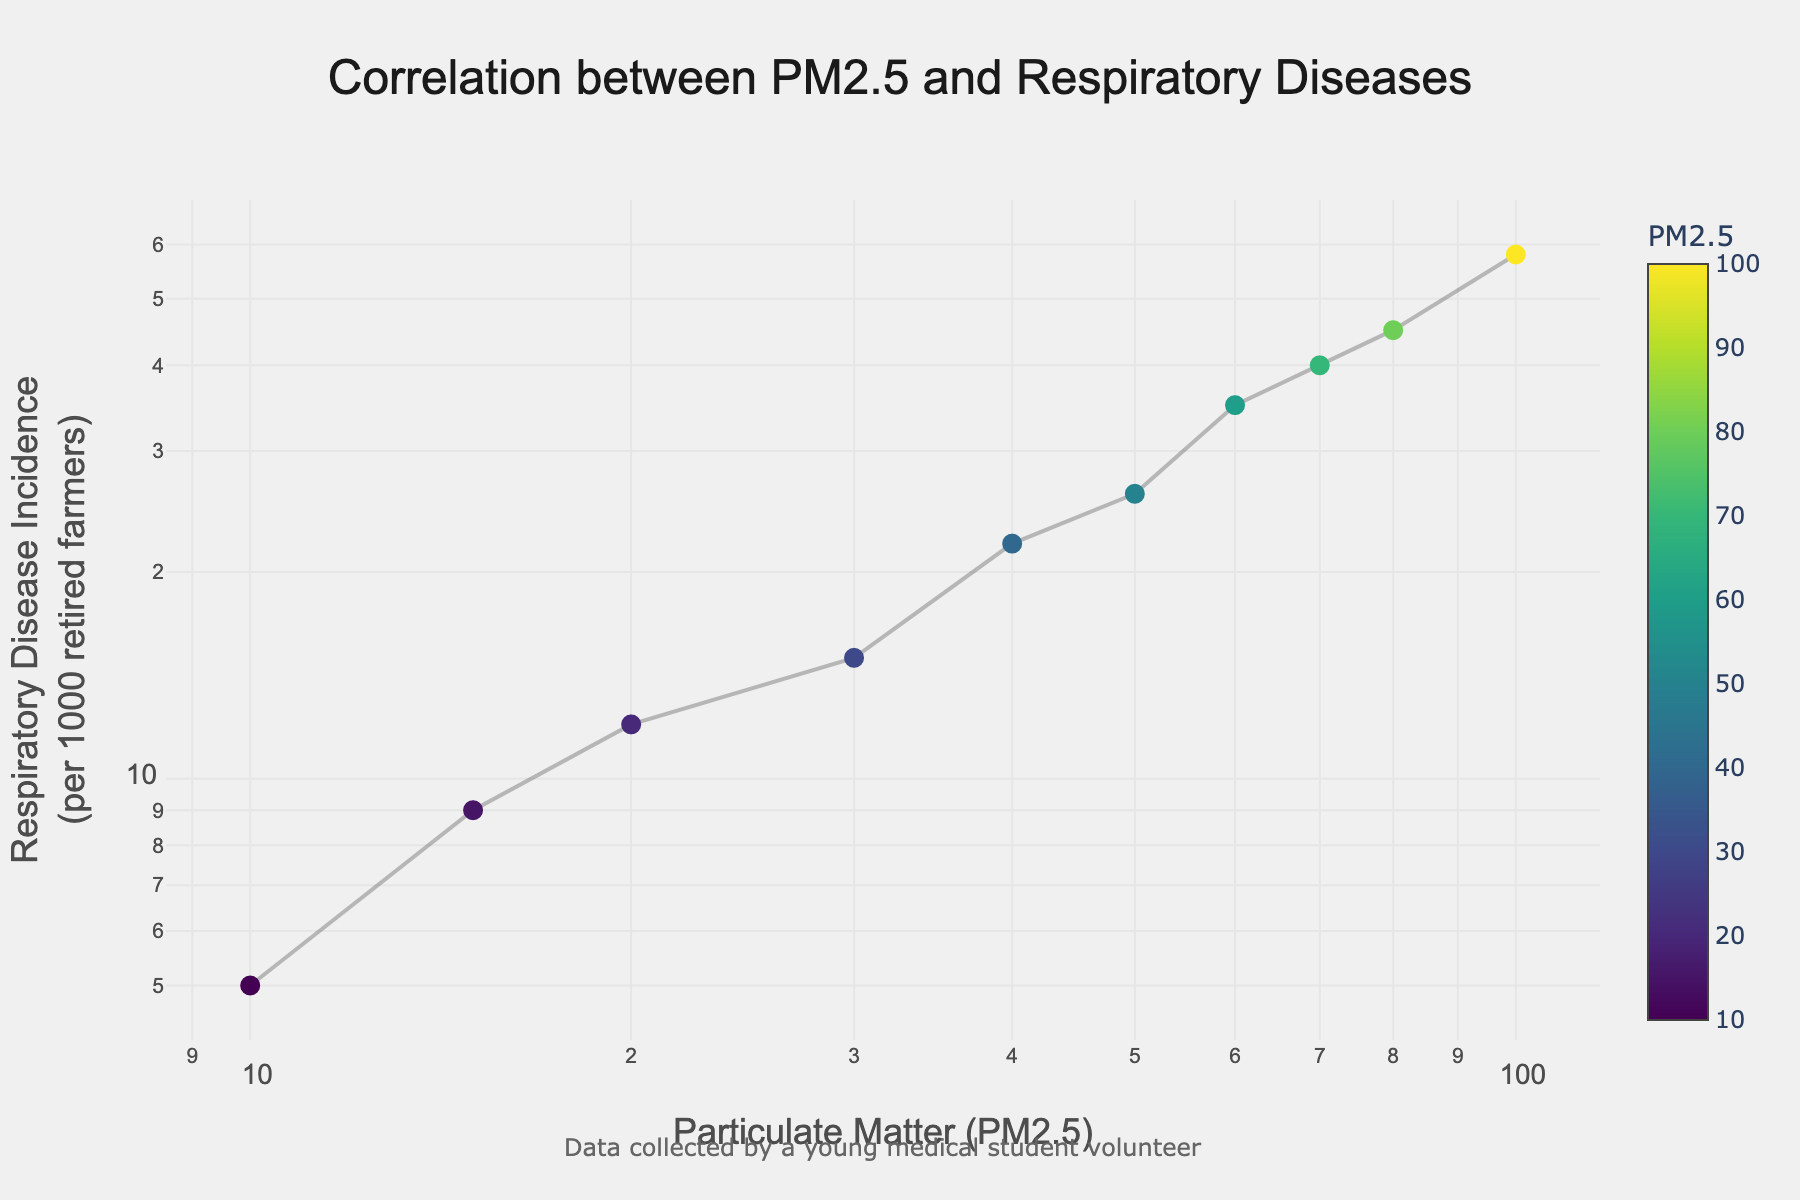Which variable is plotted on the x-axis? The x-axis plots the concentration levels of particulate matter (PM2.5)
Answer: Concentration levels of particulate matter (PM2.5) How many data points are shown in the plot? There are ten data points visible on the plot, each representing a pair of PM2.5 concentration and corresponding respiratory disease incidence.
Answer: Ten What is the title of the plot? The title of the plot is displayed at the top center and reads "Correlation between PM2.5 and Respiratory Diseases"
Answer: Correlation between PM2.5 and Respiratory Diseases What is the value of Respiratory Disease Incidence when Particulate Matter (PM2.5) is 50? Locate the point on the plot where PM2.5 is 50 and note the corresponding y-axis value, which is around 26 per 1000 retired farmers.
Answer: 26 What is the change in Respiratory Disease Incidence per 1000 retired farmers between PM2.5 levels of 40 and 80? Identify the Respiratory Disease Incidence values for PM2.5 at 40 and 80, which are 22 and 45 respectively. Compute the difference as 45 - 22.
Answer: 23 Which PM2.5 concentration level corresponds to the highest Respiratory Disease Incidence? The highest y-axis value in the plot (Respiratory Disease Incidence) is 58, corresponding to the PM2.5 concentration of 100.
Answer: 100 Is there a positive or negative correlation between PM2.5 concentration and Respiratory Disease Incidence? The plot shows that as PM2.5 concentration increases, the incidence of respiratory diseases also increases, indicating a positive correlation.
Answer: Positive correlation What is the Respiratory Disease Incidence at the lowest PM2.5 level plotted? The lowest PM2.5 concentration on the plot is 10, and the corresponding y-axis value is approximately 5.
Answer: 5 Which part of the plot uses a colorscale, and what does it represent? The color scale is applied to the markers in the scatter plot, representing different levels of PM2.5.
Answer: The markers indicating PM2.5 levels How does the plot help in understanding respiratory health among retired farmers? The plot shows the correlation between increasing PM2.5 and higher incidence rates of respiratory diseases, suggesting that higher pollution levels might aggravate health issues among retired farmers.
Answer: It shows the correlation between PM2.5 and respiratory diseases 